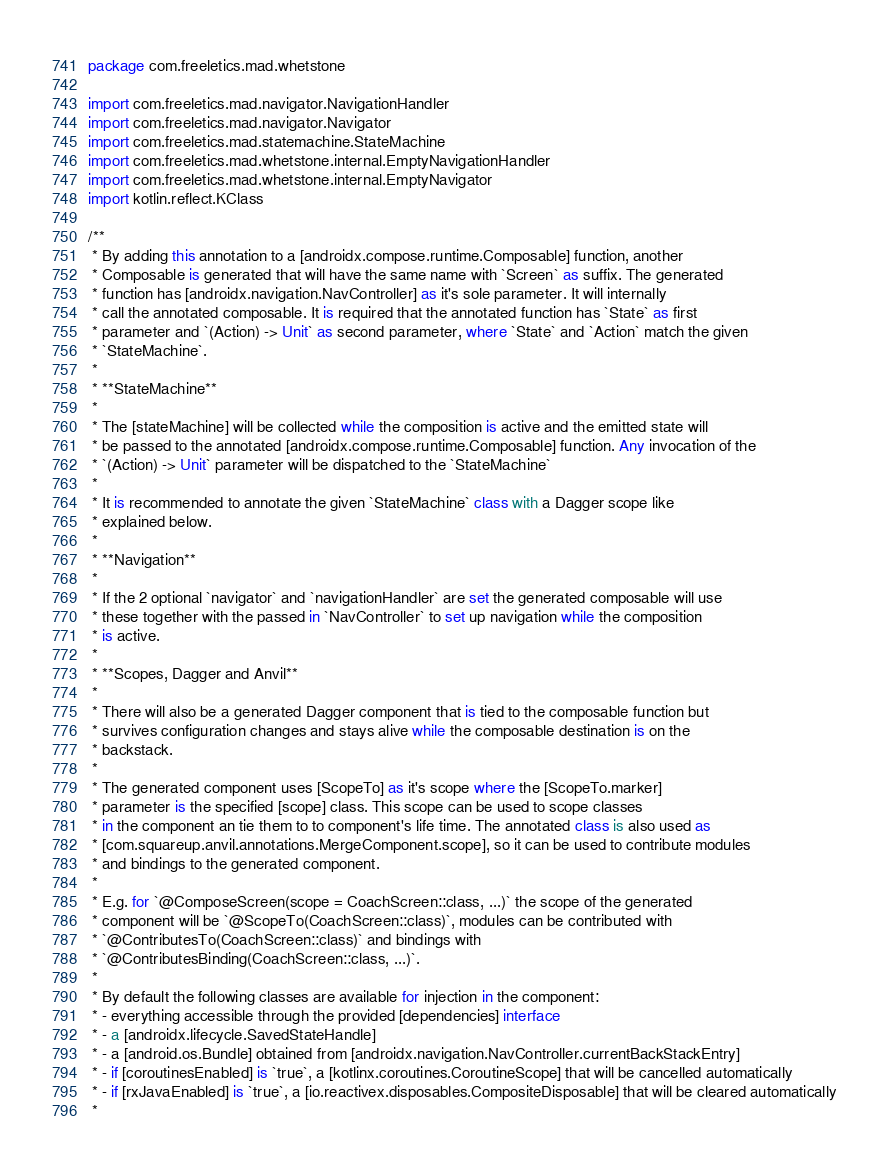Convert code to text. <code><loc_0><loc_0><loc_500><loc_500><_Kotlin_>package com.freeletics.mad.whetstone

import com.freeletics.mad.navigator.NavigationHandler
import com.freeletics.mad.navigator.Navigator
import com.freeletics.mad.statemachine.StateMachine
import com.freeletics.mad.whetstone.internal.EmptyNavigationHandler
import com.freeletics.mad.whetstone.internal.EmptyNavigator
import kotlin.reflect.KClass

/**
 * By adding this annotation to a [androidx.compose.runtime.Composable] function, another
 * Composable is generated that will have the same name with `Screen` as suffix. The generated
 * function has [androidx.navigation.NavController] as it's sole parameter. It will internally
 * call the annotated composable. It is required that the annotated function has `State` as first
 * parameter and `(Action) -> Unit` as second parameter, where `State` and `Action` match the given
 * `StateMachine`.
 *
 * **StateMachine**
 *
 * The [stateMachine] will be collected while the composition is active and the emitted state will
 * be passed to the annotated [androidx.compose.runtime.Composable] function. Any invocation of the
 * `(Action) -> Unit` parameter will be dispatched to the `StateMachine`
 *
 * It is recommended to annotate the given `StateMachine` class with a Dagger scope like
 * explained below.
 *
 * **Navigation**
 *
 * If the 2 optional `navigator` and `navigationHandler` are set the generated composable will use
 * these together with the passed in `NavController` to set up navigation while the composition
 * is active.
 *
 * **Scopes, Dagger and Anvil**
 *
 * There will also be a generated Dagger component that is tied to the composable function but
 * survives configuration changes and stays alive while the composable destination is on the
 * backstack.
 *
 * The generated component uses [ScopeTo] as it's scope where the [ScopeTo.marker]
 * parameter is the specified [scope] class. This scope can be used to scope classes
 * in the component an tie them to to component's life time. The annotated class is also used as
 * [com.squareup.anvil.annotations.MergeComponent.scope], so it can be used to contribute modules
 * and bindings to the generated component.
 *
 * E.g. for `@ComposeScreen(scope = CoachScreen::class, ...)` the scope of the generated
 * component will be `@ScopeTo(CoachScreen::class)`, modules can be contributed with
 * `@ContributesTo(CoachScreen::class)` and bindings with
 * `@ContributesBinding(CoachScreen::class, ...)`.
 *
 * By default the following classes are available for injection in the component:
 * - everything accessible through the provided [dependencies] interface
 * - a [androidx.lifecycle.SavedStateHandle]
 * - a [android.os.Bundle] obtained from [androidx.navigation.NavController.currentBackStackEntry]
 * - if [coroutinesEnabled] is `true`, a [kotlinx.coroutines.CoroutineScope] that will be cancelled automatically
 * - if [rxJavaEnabled] is `true`, a [io.reactivex.disposables.CompositeDisposable] that will be cleared automatically
 *</code> 